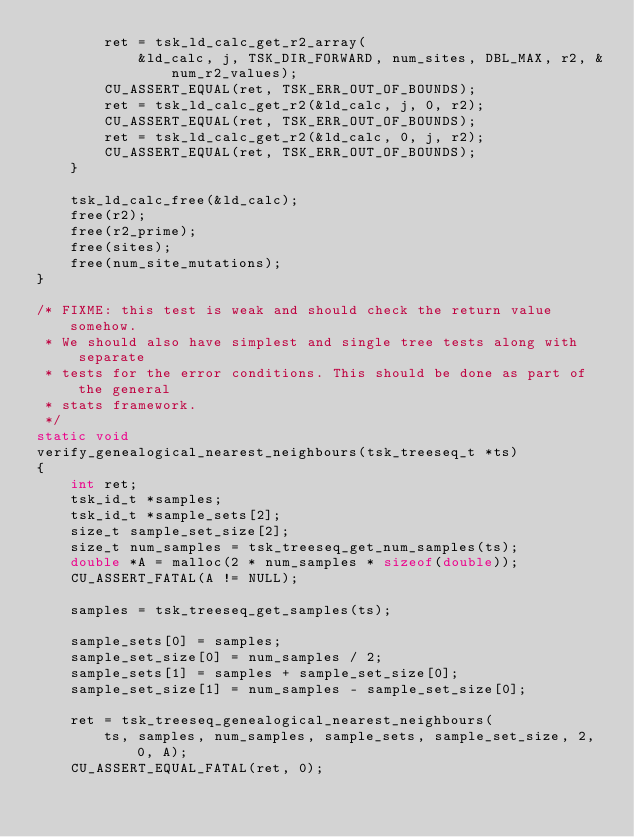<code> <loc_0><loc_0><loc_500><loc_500><_C_>        ret = tsk_ld_calc_get_r2_array(
            &ld_calc, j, TSK_DIR_FORWARD, num_sites, DBL_MAX, r2, &num_r2_values);
        CU_ASSERT_EQUAL(ret, TSK_ERR_OUT_OF_BOUNDS);
        ret = tsk_ld_calc_get_r2(&ld_calc, j, 0, r2);
        CU_ASSERT_EQUAL(ret, TSK_ERR_OUT_OF_BOUNDS);
        ret = tsk_ld_calc_get_r2(&ld_calc, 0, j, r2);
        CU_ASSERT_EQUAL(ret, TSK_ERR_OUT_OF_BOUNDS);
    }

    tsk_ld_calc_free(&ld_calc);
    free(r2);
    free(r2_prime);
    free(sites);
    free(num_site_mutations);
}

/* FIXME: this test is weak and should check the return value somehow.
 * We should also have simplest and single tree tests along with separate
 * tests for the error conditions. This should be done as part of the general
 * stats framework.
 */
static void
verify_genealogical_nearest_neighbours(tsk_treeseq_t *ts)
{
    int ret;
    tsk_id_t *samples;
    tsk_id_t *sample_sets[2];
    size_t sample_set_size[2];
    size_t num_samples = tsk_treeseq_get_num_samples(ts);
    double *A = malloc(2 * num_samples * sizeof(double));
    CU_ASSERT_FATAL(A != NULL);

    samples = tsk_treeseq_get_samples(ts);

    sample_sets[0] = samples;
    sample_set_size[0] = num_samples / 2;
    sample_sets[1] = samples + sample_set_size[0];
    sample_set_size[1] = num_samples - sample_set_size[0];

    ret = tsk_treeseq_genealogical_nearest_neighbours(
        ts, samples, num_samples, sample_sets, sample_set_size, 2, 0, A);
    CU_ASSERT_EQUAL_FATAL(ret, 0);
</code> 